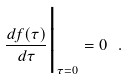<formula> <loc_0><loc_0><loc_500><loc_500>\frac { d f ( \tau ) } { d \tau } \Big | _ { \tau = 0 } = 0 \ .</formula> 